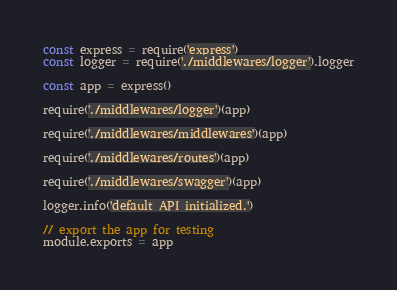<code> <loc_0><loc_0><loc_500><loc_500><_JavaScript_>const express = require('express')
const logger = require('./middlewares/logger').logger

const app = express()

require('./middlewares/logger')(app)

require('./middlewares/middlewares')(app)

require('./middlewares/routes')(app)

require('./middlewares/swagger')(app)

logger.info('default API initialized.')

// export the app for testing
module.exports = app
</code> 